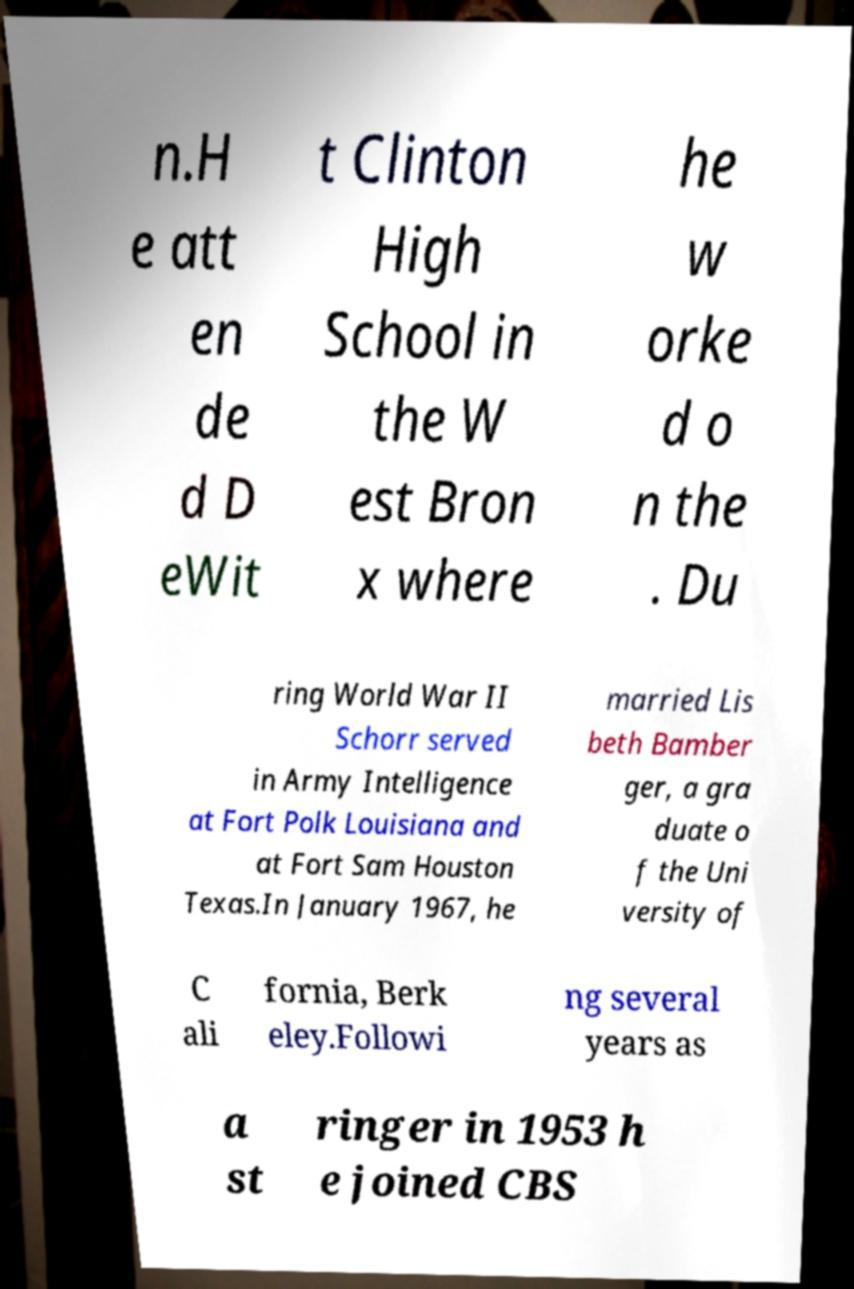I need the written content from this picture converted into text. Can you do that? n.H e att en de d D eWit t Clinton High School in the W est Bron x where he w orke d o n the . Du ring World War II Schorr served in Army Intelligence at Fort Polk Louisiana and at Fort Sam Houston Texas.In January 1967, he married Lis beth Bamber ger, a gra duate o f the Uni versity of C ali fornia, Berk eley.Followi ng several years as a st ringer in 1953 h e joined CBS 